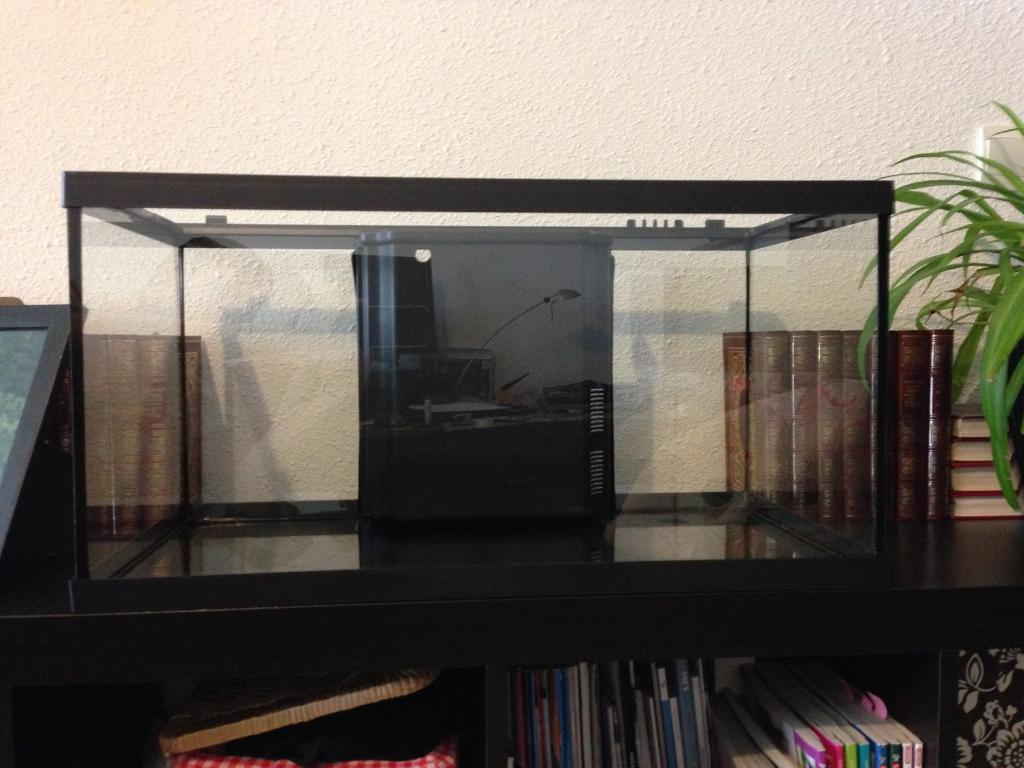What is the main object in the image? There is an aquarium in the image. What else can be seen in the image besides the aquarium? There are books and a plant in the image. What is the background of the image? There is a wall in the image. What type of verse can be heard recited by the plant in the image? There is no verse being recited by the plant in the image, as plants do not have the ability to recite verses. 